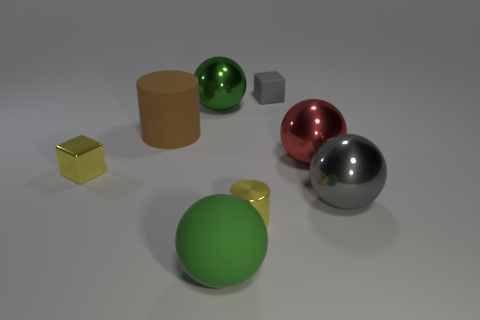How many things are big green rubber balls or small yellow cubes?
Provide a short and direct response. 2. What shape is the large thing that is the same color as the small rubber object?
Ensure brevity in your answer.  Sphere. There is a shiny thing that is left of the gray ball and in front of the small yellow block; what is its size?
Give a very brief answer. Small. How many yellow things are there?
Your answer should be compact. 2. How many balls are small metallic objects or rubber things?
Offer a terse response. 1. There is a gray object that is on the right side of the matte object behind the big green metal thing; what number of matte cylinders are in front of it?
Your response must be concise. 0. There is a rubber cylinder that is the same size as the green metal thing; what color is it?
Ensure brevity in your answer.  Brown. What number of other objects are there of the same color as the tiny cylinder?
Give a very brief answer. 1. Are there more red metallic balls right of the green rubber thing than large gray matte blocks?
Your answer should be very brief. Yes. Do the tiny gray object and the small yellow cylinder have the same material?
Your answer should be compact. No. 